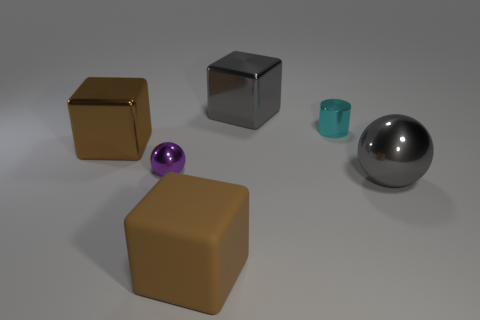The shiny thing that is on the right side of the large brown rubber cube and left of the cyan cylinder has what shape? cube 